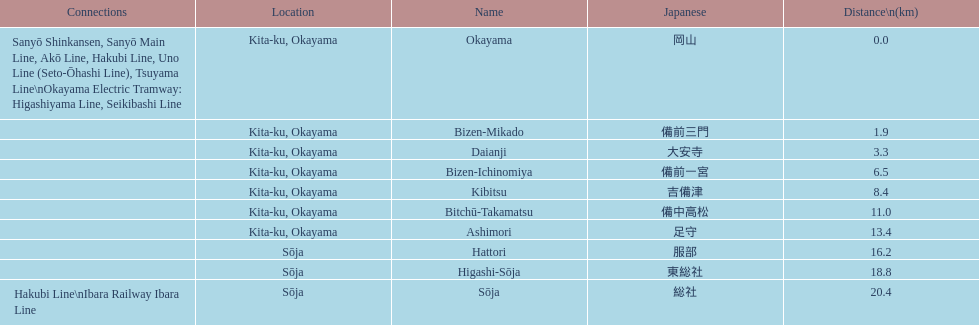How many station are located in kita-ku, okayama? 7. 